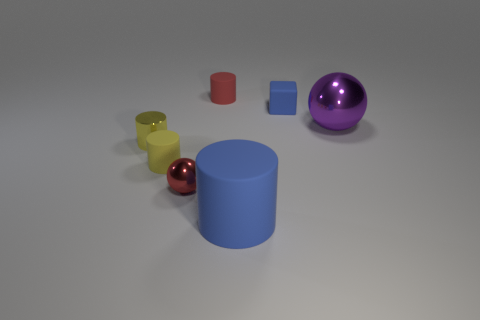How does the lighting affect the appearance of the objects? The lighting in the image creates soft shadows and subtle highlights on the objects, enhancing their three-dimensional appearance. It appears central above the objects, casting shadows that are relatively short, suggesting a broad and even light source. It seems to be diffused, resulting in soft edges on shadows, which helps distinguish the textural qualities of each material. 